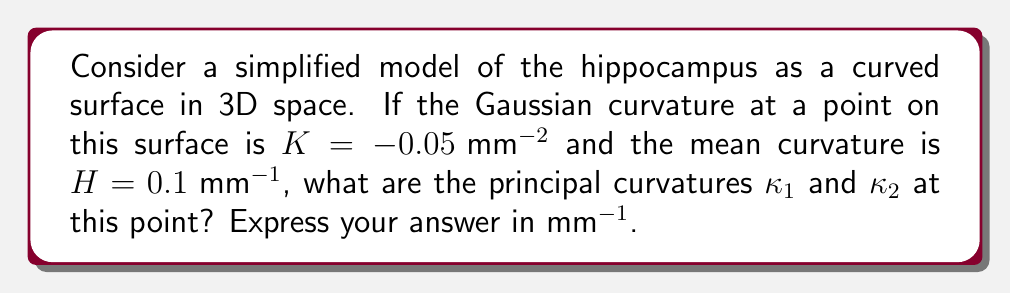Show me your answer to this math problem. To solve this problem, we'll use the relationships between Gaussian curvature ($K$), mean curvature ($H$), and principal curvatures ($\kappa_1$ and $\kappa_2$):

1) The Gaussian curvature is the product of the principal curvatures:
   $$K = \kappa_1 \kappa_2$$

2) The mean curvature is the average of the principal curvatures:
   $$H = \frac{\kappa_1 + \kappa_2}{2}$$

Given:
$K = -0.05 \text{ mm}^{-2}$
$H = 0.1 \text{ mm}^{-1}$

3) From the mean curvature equation:
   $$\kappa_1 + \kappa_2 = 2H = 2(0.1) = 0.2 \text{ mm}^{-1}$$

4) Let $\kappa_1 = x$. Then $\kappa_2 = 0.2 - x$.

5) Substitute these into the Gaussian curvature equation:
   $$K = \kappa_1 \kappa_2$$
   $$-0.05 = x(0.2 - x)$$
   $$-0.05 = 0.2x - x^2$$

6) Rearrange the equation:
   $$x^2 - 0.2x - 0.05 = 0$$

7) Solve this quadratic equation using the quadratic formula:
   $$x = \frac{-b \pm \sqrt{b^2 - 4ac}}{2a}$$
   $$x = \frac{0.2 \pm \sqrt{0.04 + 0.2}}{2} = \frac{0.2 \pm \sqrt{0.24}}{2}$$

8) Simplify:
   $$x = \frac{0.2 \pm 0.4899}{2}$$

9) This gives us two solutions:
   $$\kappa_1 = 0.3449 \text{ mm}^{-1}$$
   $$\kappa_2 = -0.1449 \text{ mm}^{-1}$$

Note that the negative curvature indicates a concave shape in that direction, which is consistent with the shape of the hippocampus.
Answer: $\kappa_1 = 0.3449 \text{ mm}^{-1}$, $\kappa_2 = -0.1449 \text{ mm}^{-1}$ 